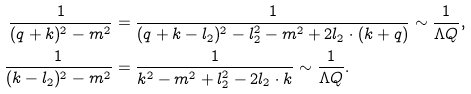Convert formula to latex. <formula><loc_0><loc_0><loc_500><loc_500>\frac { 1 } { ( q + k ) ^ { 2 } - m ^ { 2 } } & = \frac { 1 } { ( q + k - l _ { 2 } ) ^ { 2 } - l _ { 2 } ^ { 2 } - m ^ { 2 } + 2 l _ { 2 } \cdot ( k + q ) } \sim \frac { 1 } { \Lambda Q } , \\ \frac { 1 } { ( k - l _ { 2 } ) ^ { 2 } - m ^ { 2 } } & = \frac { 1 } { k ^ { 2 } - m ^ { 2 } + l _ { 2 } ^ { 2 } - 2 l _ { 2 } \cdot k } \sim \frac { 1 } { \Lambda Q } .</formula> 